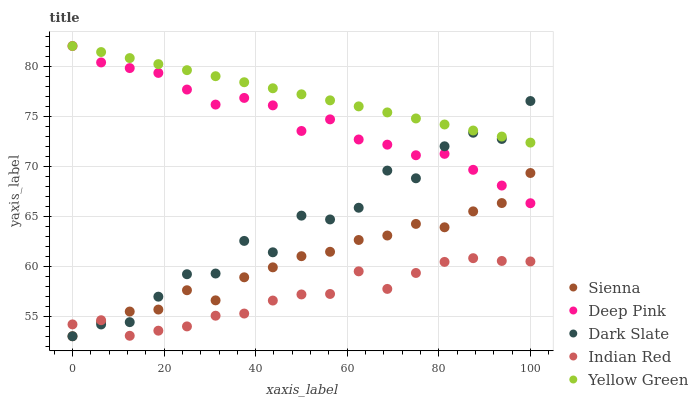Does Indian Red have the minimum area under the curve?
Answer yes or no. Yes. Does Yellow Green have the maximum area under the curve?
Answer yes or no. Yes. Does Dark Slate have the minimum area under the curve?
Answer yes or no. No. Does Dark Slate have the maximum area under the curve?
Answer yes or no. No. Is Yellow Green the smoothest?
Answer yes or no. Yes. Is Dark Slate the roughest?
Answer yes or no. Yes. Is Deep Pink the smoothest?
Answer yes or no. No. Is Deep Pink the roughest?
Answer yes or no. No. Does Sienna have the lowest value?
Answer yes or no. Yes. Does Deep Pink have the lowest value?
Answer yes or no. No. Does Yellow Green have the highest value?
Answer yes or no. Yes. Does Dark Slate have the highest value?
Answer yes or no. No. Is Sienna less than Yellow Green?
Answer yes or no. Yes. Is Yellow Green greater than Sienna?
Answer yes or no. Yes. Does Deep Pink intersect Sienna?
Answer yes or no. Yes. Is Deep Pink less than Sienna?
Answer yes or no. No. Is Deep Pink greater than Sienna?
Answer yes or no. No. Does Sienna intersect Yellow Green?
Answer yes or no. No. 